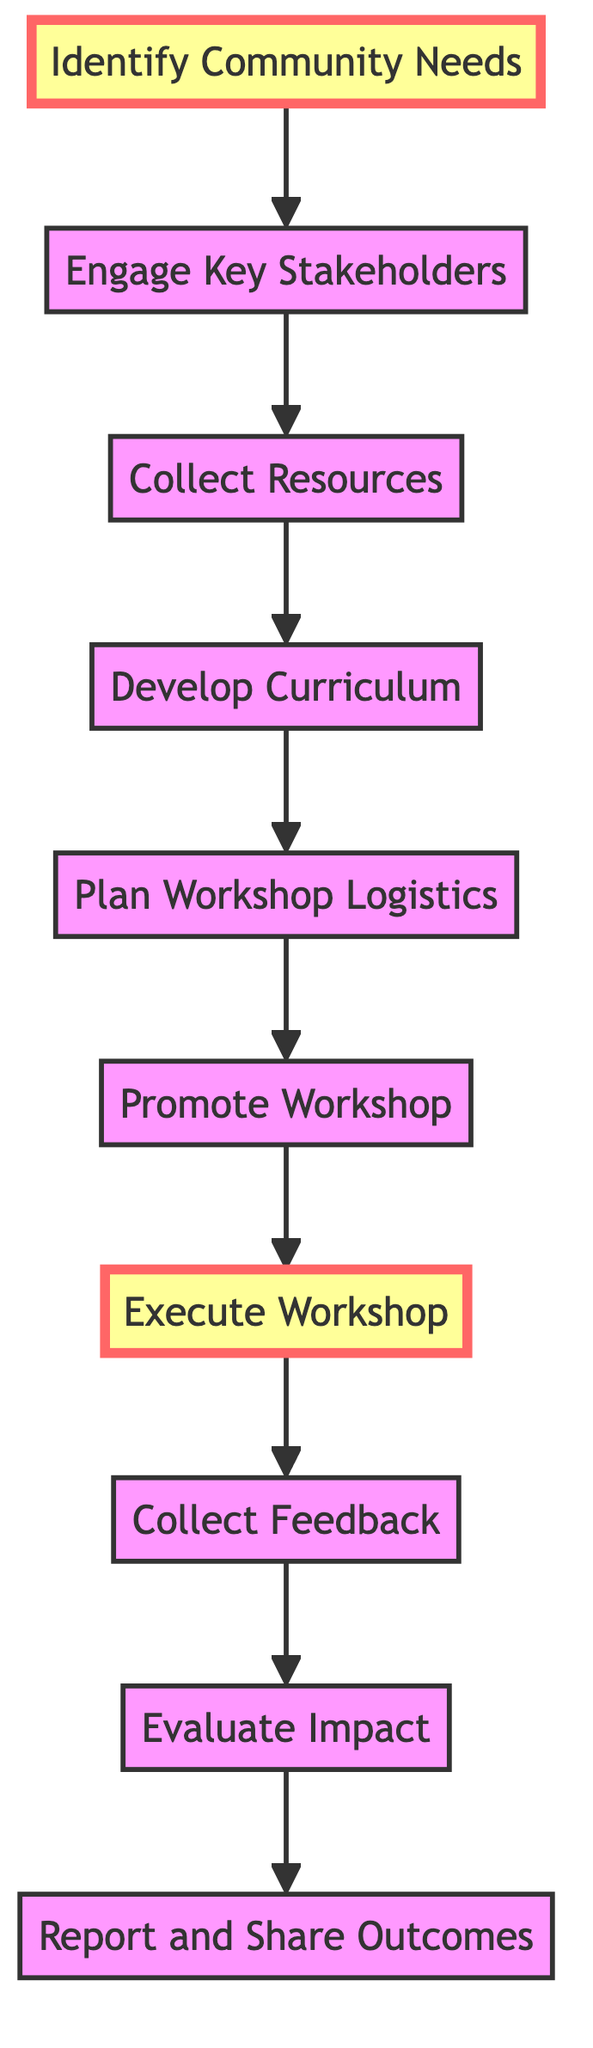What is the first step in organizing a community language learning workshop? The diagram shows that the first step is "Identify Community Needs," which is the first node in the flow of the process.
Answer: Identify Community Needs How many nodes are in the diagram? By counting each unique labeled element in the diagram, we find there are ten nodes listed, each representing a step in the process.
Answer: 10 What is the last step after evaluating the impact? The final step in the diagram after "Evaluate Impact" is "Report and Share Outcomes," which is the concluding action before concluding the workshop process.
Answer: Report and Share Outcomes What step comes directly after promoting the workshop? Following the "Promote Workshop" node, the next action is "Execute Workshop," indicating the order in which these steps occur.
Answer: Execute Workshop What is the relationship between "Collect Feedback" and "Evaluate Impact"? The directed edge connects "Collect Feedback" to "Evaluate Impact," indicating that feedback collection is a prerequisite for evaluating the overall impact of the workshop.
Answer: Collect Feedback → Evaluate Impact Which step involves engaging key stakeholders? In the diagram, "Engage Key Stakeholders" is labeled clearly and is the second step in the flow following the identification of community needs.
Answer: Engage Key Stakeholders How many edges are present in the diagram? By examining the connections between the nodes, we see there are nine directed edges connecting the ten nodes, which signify the progression through the workshop organization steps.
Answer: 9 What is the primary purpose of the "Develop Curriculum" step? The diagram denotes that "Develop Curriculum" is aimed at creating educational material and structure for the workshop, based on the resources gathered in the previous step.
Answer: Develop Curriculum What action must be completed before the execution of the workshop? Before executing the workshop, the previous step "Plan Workshop Logistics" must be finished to ensure all elements are arranged and in order.
Answer: Plan Workshop Logistics 